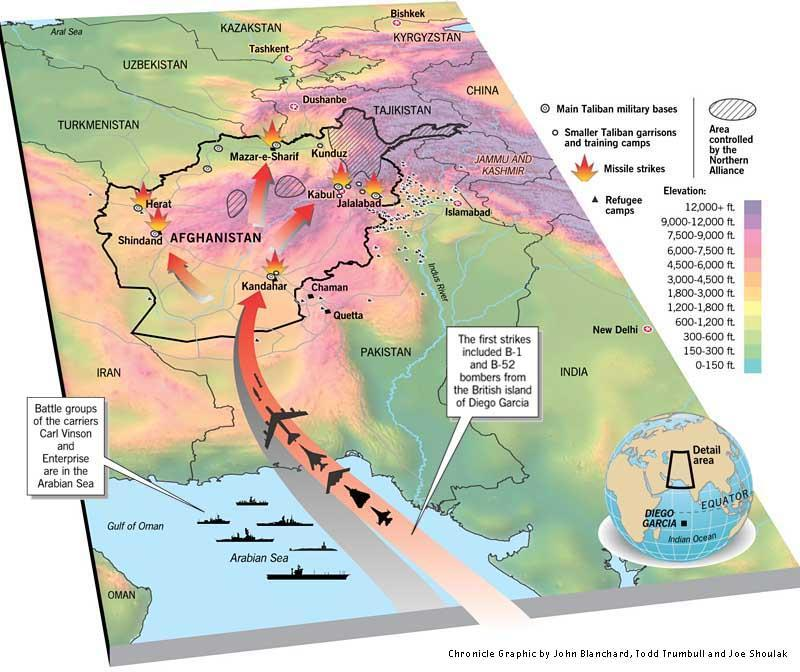How many missile strikes were made?
Answer the question with a short phrase. 5 What was the target of the missiles; Taliban garrisons or Taliban military bases? Taliban military bases How many smaller Taliban garrisons and training camps were there in Afghanistan? 6 Which city in Afghanistan has a Taliban military base, Taliban garrison and a refugee camp? Kandahar How many main Taliban military bases are located in Afghanistan? 8 Where are the battle groups in the ships? Arabian sea From where did US make the first strikes against Afghanistan? Diego Garcia Which were the two ships used by the battle groups? Carl Vinson, Enterprise Which were the bombers used in the first strike? B-1 and B-52 How many refugee camps are there in Kandahar? 1 